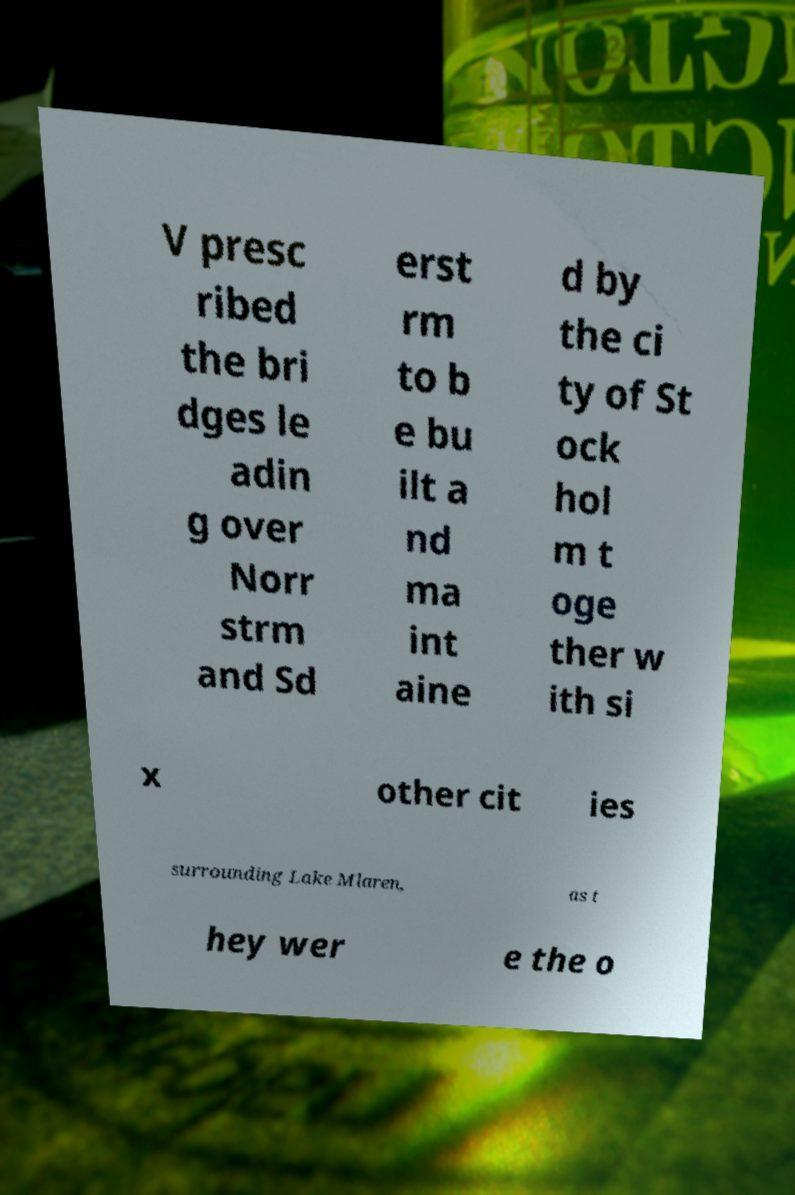Could you extract and type out the text from this image? V presc ribed the bri dges le adin g over Norr strm and Sd erst rm to b e bu ilt a nd ma int aine d by the ci ty of St ock hol m t oge ther w ith si x other cit ies surrounding Lake Mlaren, as t hey wer e the o 